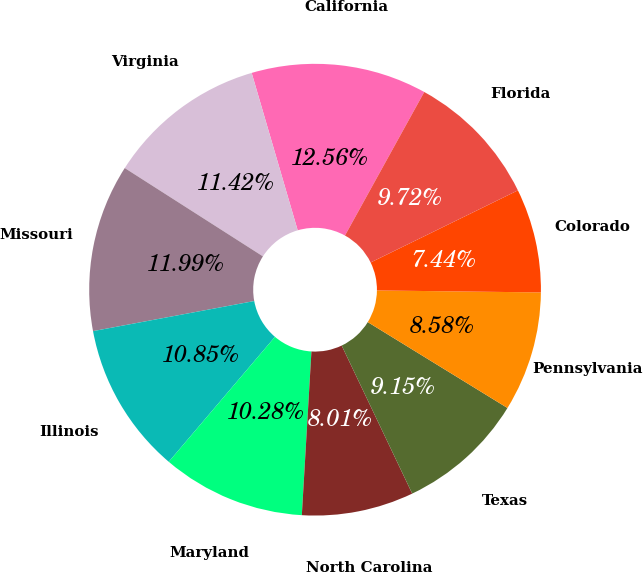<chart> <loc_0><loc_0><loc_500><loc_500><pie_chart><fcel>California<fcel>Virginia<fcel>Missouri<fcel>Illinois<fcel>Maryland<fcel>North Carolina<fcel>Texas<fcel>Pennsylvania<fcel>Colorado<fcel>Florida<nl><fcel>12.56%<fcel>11.42%<fcel>11.99%<fcel>10.85%<fcel>10.28%<fcel>8.01%<fcel>9.15%<fcel>8.58%<fcel>7.44%<fcel>9.72%<nl></chart> 